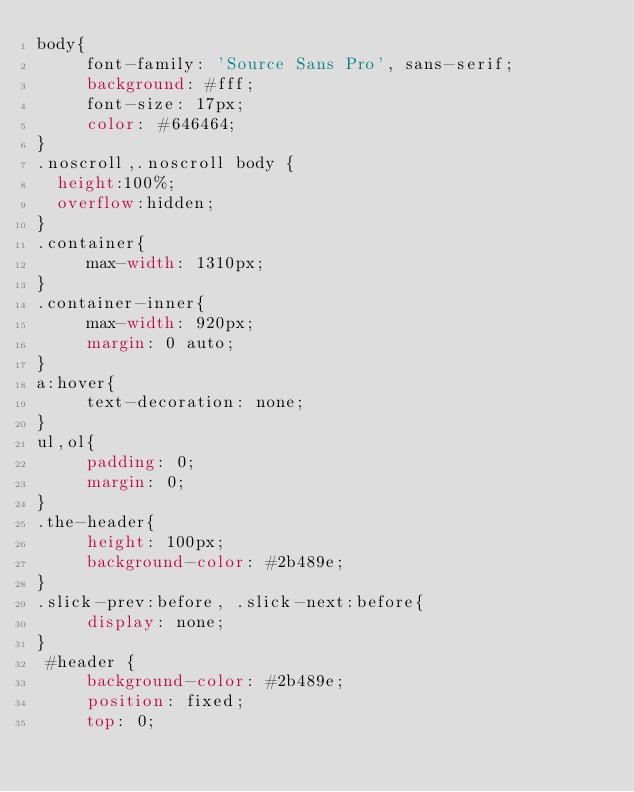Convert code to text. <code><loc_0><loc_0><loc_500><loc_500><_CSS_>body{
     font-family: 'Source Sans Pro', sans-serif;
     background: #fff;
     font-size: 17px;
     color: #646464;
}
.noscroll,.noscroll body {
	height:100%;
	overflow:hidden;
}
.container{
     max-width: 1310px;
}
.container-inner{
     max-width: 920px;
     margin: 0 auto;
}
a:hover{
     text-decoration: none;
}
ul,ol{
     padding: 0;
     margin: 0;
}
.the-header{
     height: 100px;
     background-color: #2b489e;
}
.slick-prev:before, .slick-next:before{
     display: none;
}
 #header {
     background-color: #2b489e;
     position: fixed;
     top: 0;</code> 